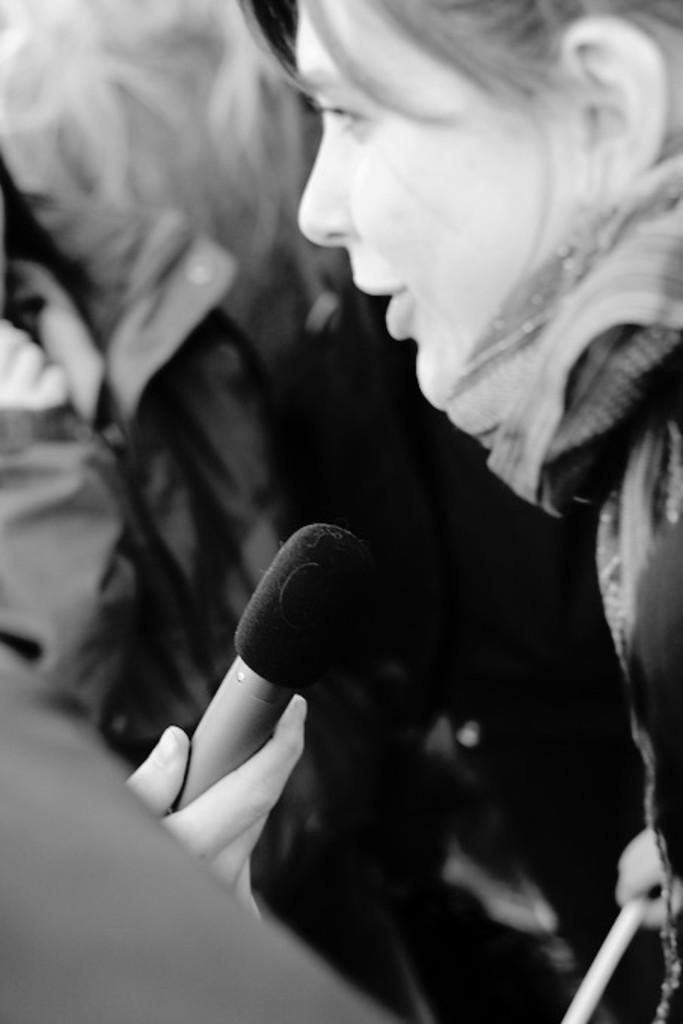In one or two sentences, can you explain what this image depicts? This is a black and white image. Here I can see few people. On the left side, I can see a person's hand holding a mike. 